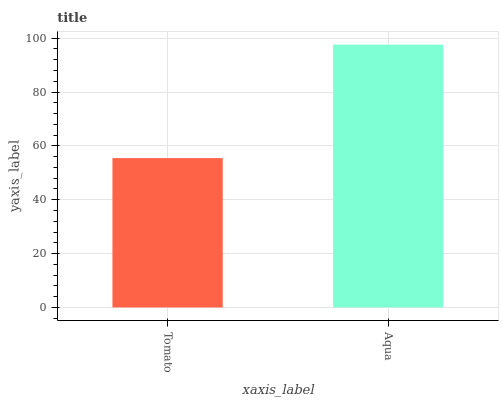Is Tomato the minimum?
Answer yes or no. Yes. Is Aqua the maximum?
Answer yes or no. Yes. Is Aqua the minimum?
Answer yes or no. No. Is Aqua greater than Tomato?
Answer yes or no. Yes. Is Tomato less than Aqua?
Answer yes or no. Yes. Is Tomato greater than Aqua?
Answer yes or no. No. Is Aqua less than Tomato?
Answer yes or no. No. Is Aqua the high median?
Answer yes or no. Yes. Is Tomato the low median?
Answer yes or no. Yes. Is Tomato the high median?
Answer yes or no. No. Is Aqua the low median?
Answer yes or no. No. 